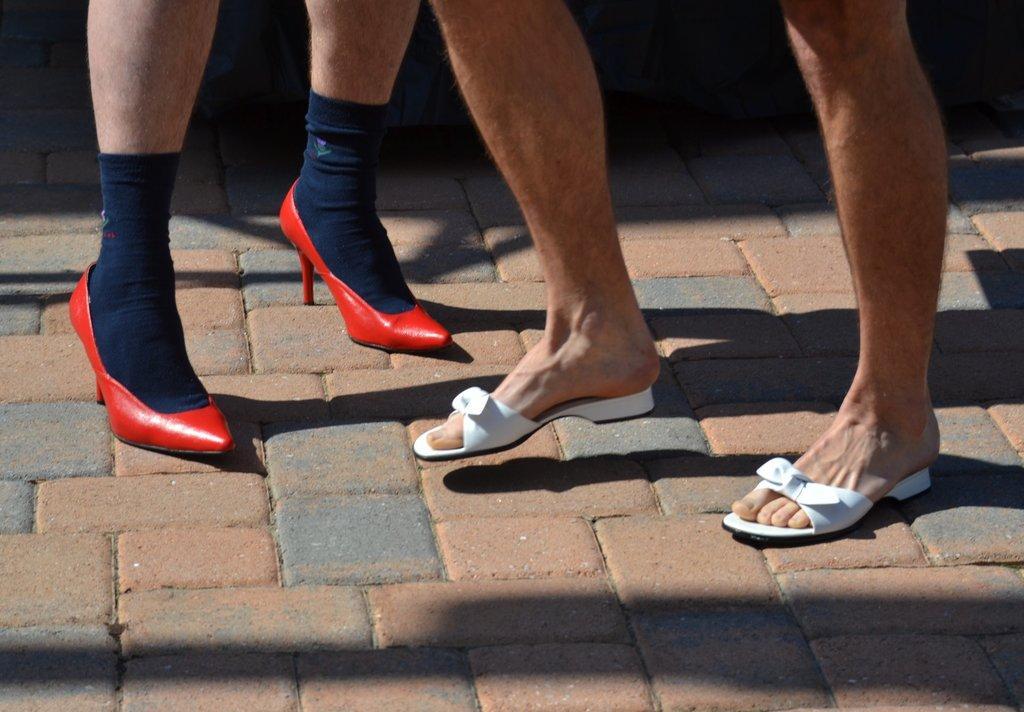Could you give a brief overview of what you see in this image? In this image there are legs of the persons visible wearing footwear which are white and red in colour and there is a sock which is blue in colour which is on the leg of the person. 